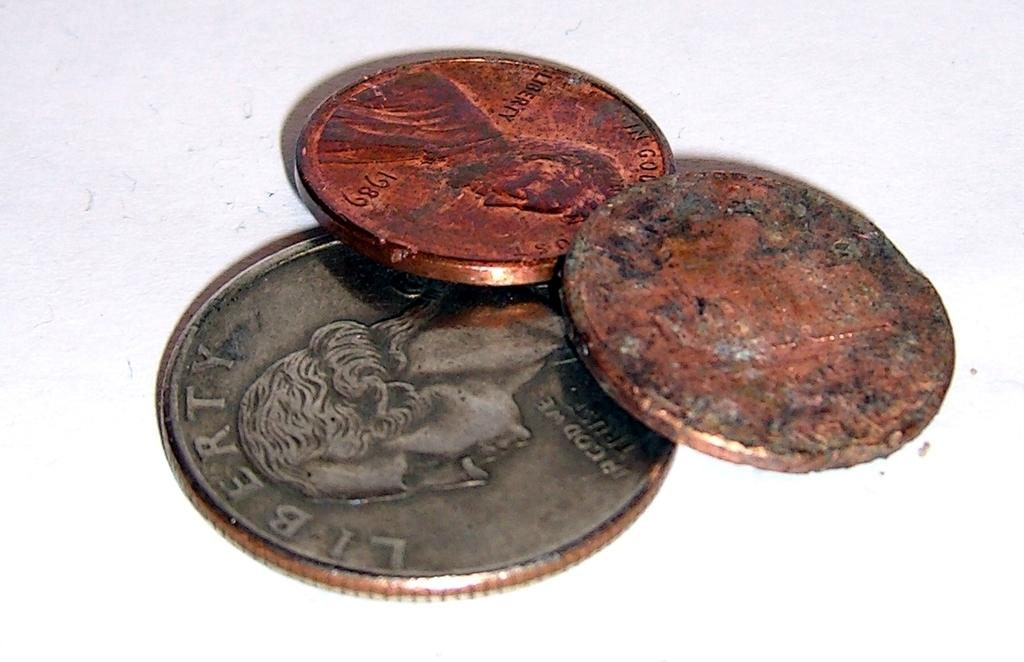Provide a one-sentence caption for the provided image. A 1989 penny is among the three coins. 